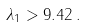<formula> <loc_0><loc_0><loc_500><loc_500>\lambda _ { 1 } > 9 . 4 2 \, .</formula> 